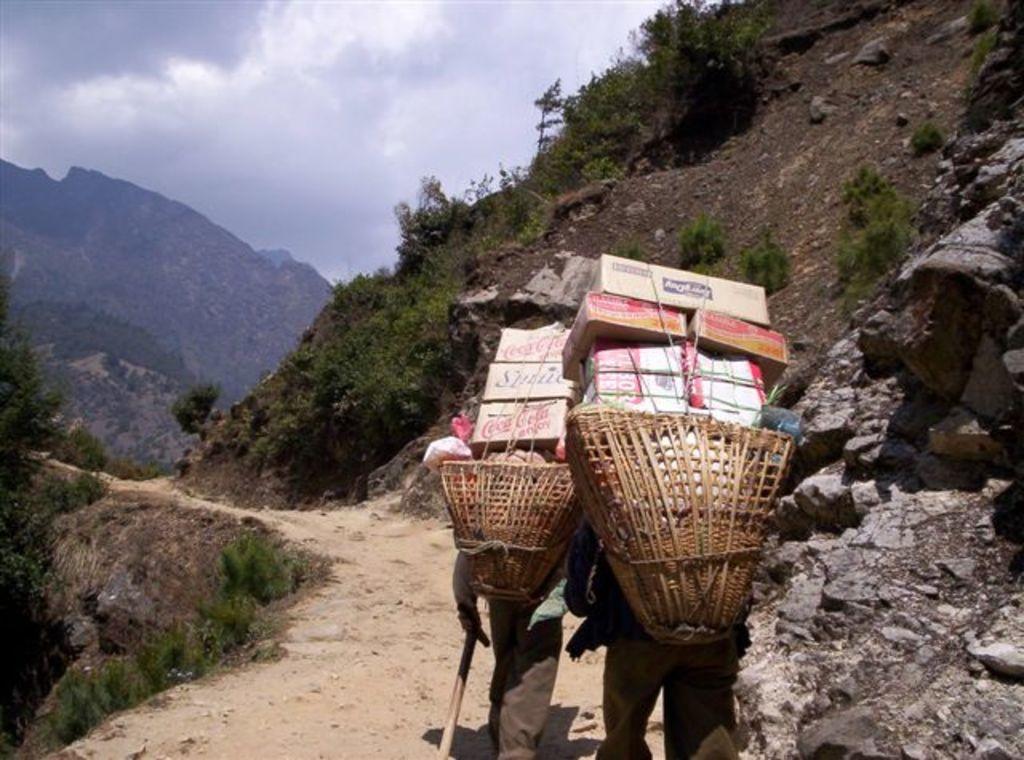In one or two sentences, can you explain what this image depicts? In this image, we can see two people are walking on the walkway. Here there are two baskets filled with objects. Background we can see hills, trees, plants and sky. Right side of the image, we can see rocks. 